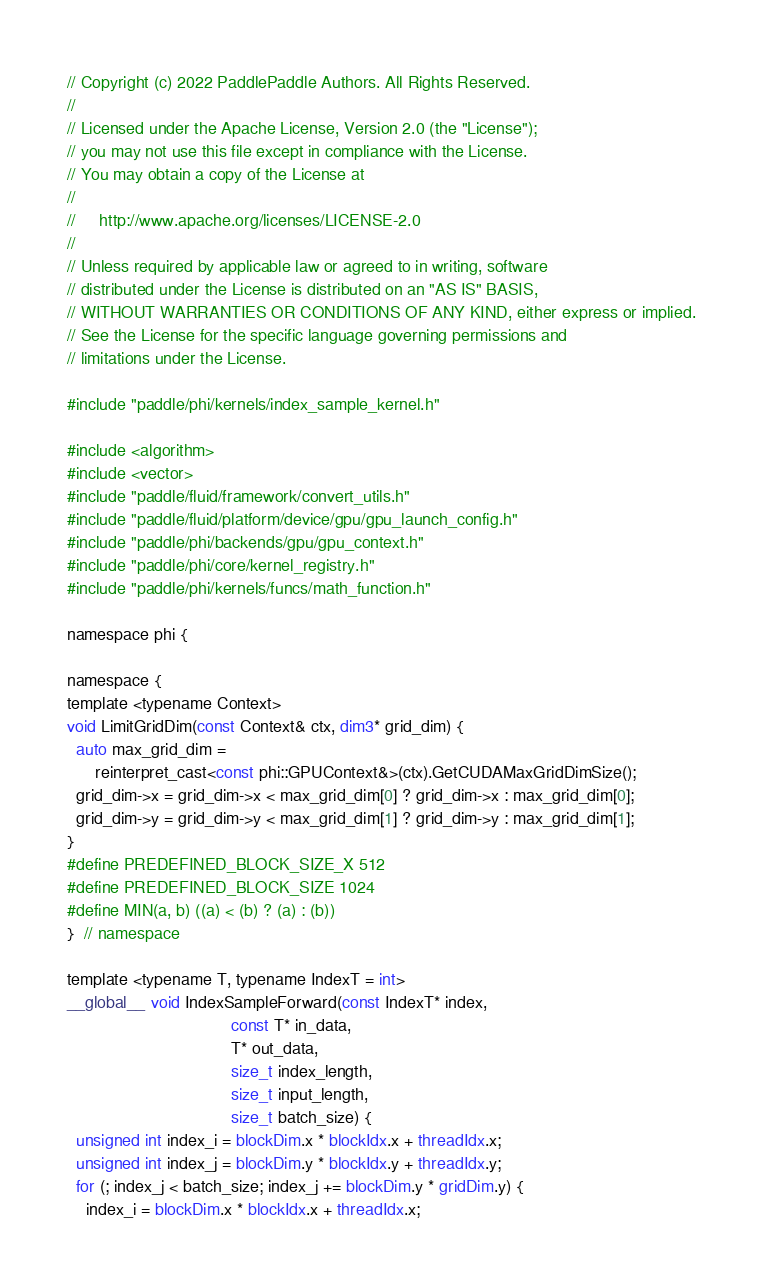Convert code to text. <code><loc_0><loc_0><loc_500><loc_500><_Cuda_>// Copyright (c) 2022 PaddlePaddle Authors. All Rights Reserved.
//
// Licensed under the Apache License, Version 2.0 (the "License");
// you may not use this file except in compliance with the License.
// You may obtain a copy of the License at
//
//     http://www.apache.org/licenses/LICENSE-2.0
//
// Unless required by applicable law or agreed to in writing, software
// distributed under the License is distributed on an "AS IS" BASIS,
// WITHOUT WARRANTIES OR CONDITIONS OF ANY KIND, either express or implied.
// See the License for the specific language governing permissions and
// limitations under the License.

#include "paddle/phi/kernels/index_sample_kernel.h"

#include <algorithm>
#include <vector>
#include "paddle/fluid/framework/convert_utils.h"
#include "paddle/fluid/platform/device/gpu/gpu_launch_config.h"
#include "paddle/phi/backends/gpu/gpu_context.h"
#include "paddle/phi/core/kernel_registry.h"
#include "paddle/phi/kernels/funcs/math_function.h"

namespace phi {

namespace {
template <typename Context>
void LimitGridDim(const Context& ctx, dim3* grid_dim) {
  auto max_grid_dim =
      reinterpret_cast<const phi::GPUContext&>(ctx).GetCUDAMaxGridDimSize();
  grid_dim->x = grid_dim->x < max_grid_dim[0] ? grid_dim->x : max_grid_dim[0];
  grid_dim->y = grid_dim->y < max_grid_dim[1] ? grid_dim->y : max_grid_dim[1];
}
#define PREDEFINED_BLOCK_SIZE_X 512
#define PREDEFINED_BLOCK_SIZE 1024
#define MIN(a, b) ((a) < (b) ? (a) : (b))
}  // namespace

template <typename T, typename IndexT = int>
__global__ void IndexSampleForward(const IndexT* index,
                                   const T* in_data,
                                   T* out_data,
                                   size_t index_length,
                                   size_t input_length,
                                   size_t batch_size) {
  unsigned int index_i = blockDim.x * blockIdx.x + threadIdx.x;
  unsigned int index_j = blockDim.y * blockIdx.y + threadIdx.y;
  for (; index_j < batch_size; index_j += blockDim.y * gridDim.y) {
    index_i = blockDim.x * blockIdx.x + threadIdx.x;</code> 